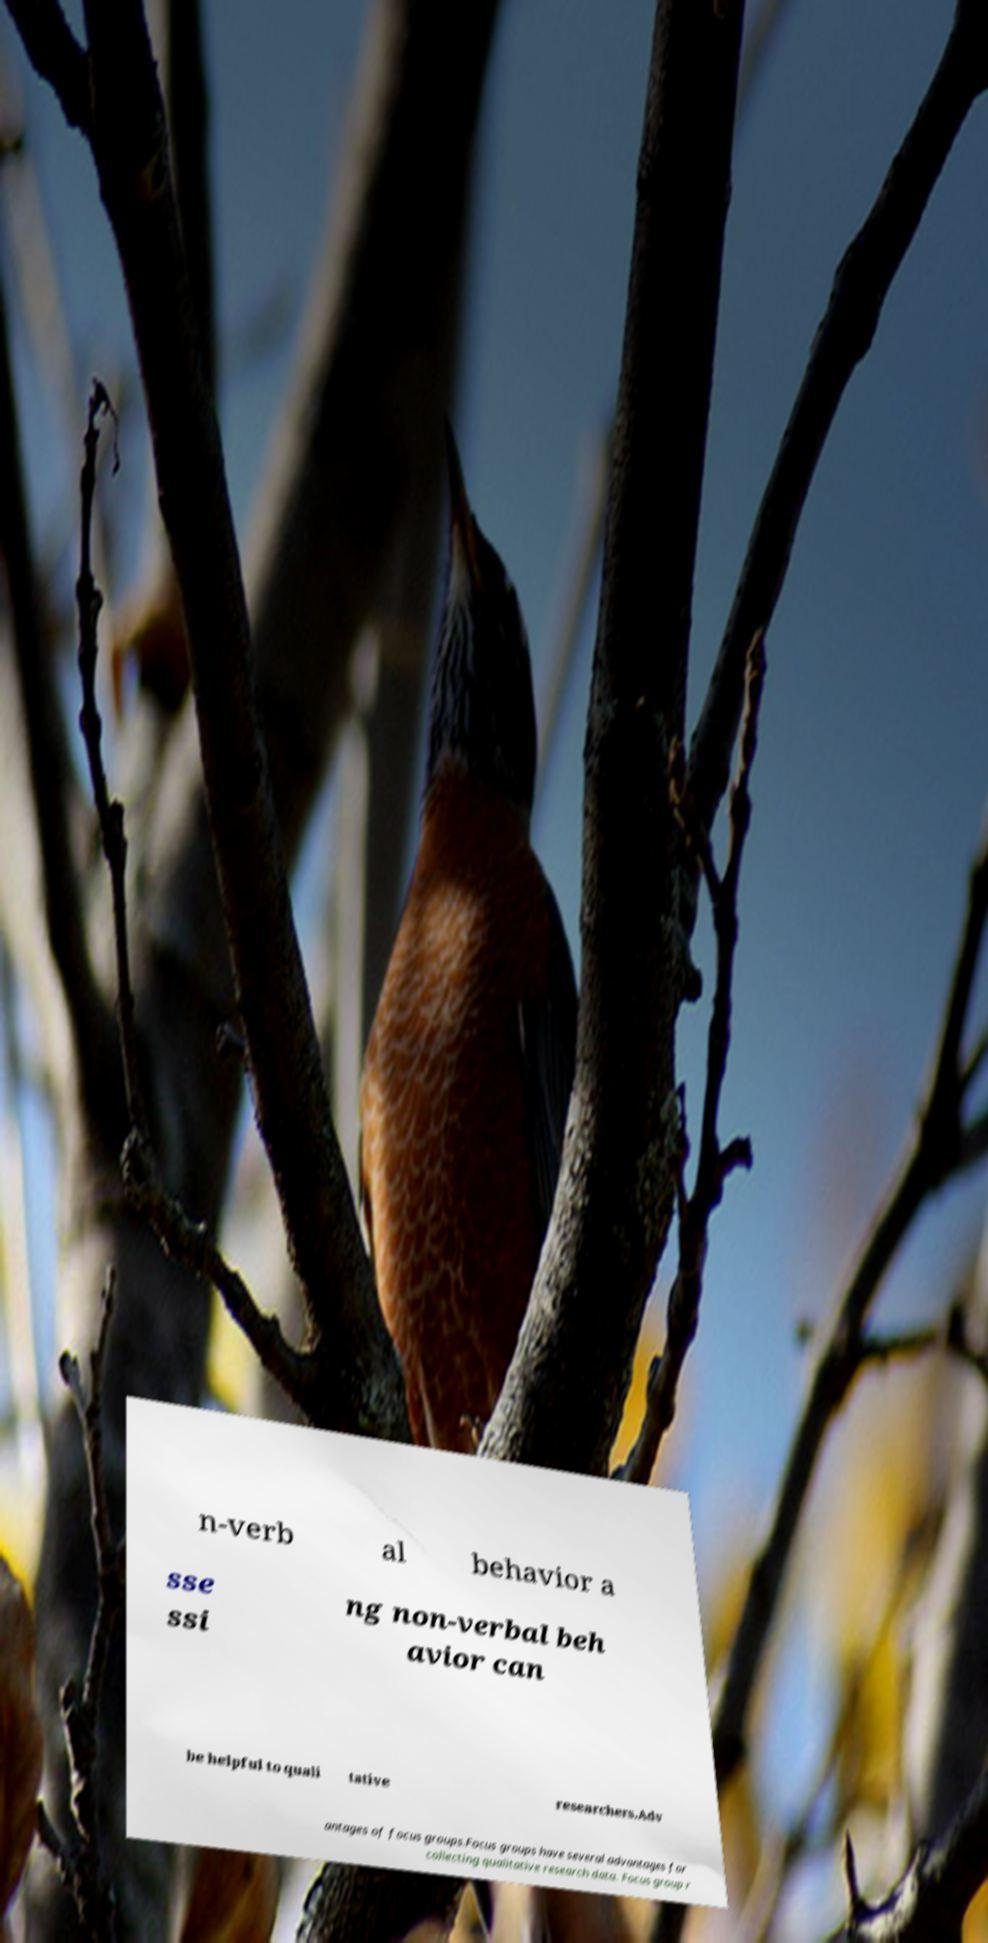Please identify and transcribe the text found in this image. n-verb al behavior a sse ssi ng non-verbal beh avior can be helpful to quali tative researchers.Adv antages of focus groups.Focus groups have several advantages for collecting qualitative research data. Focus group r 